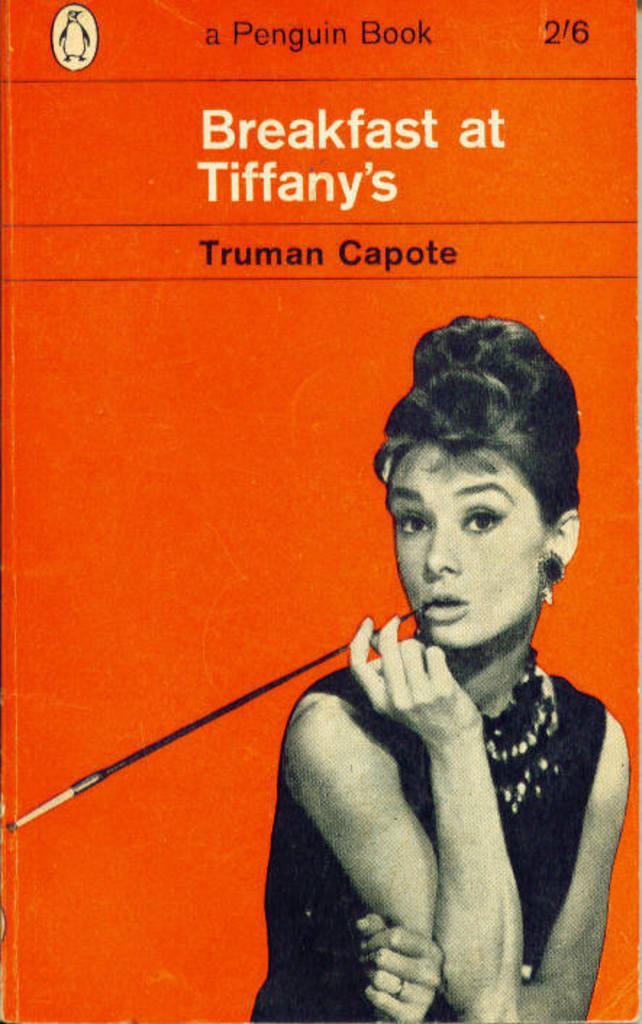Could you give a brief overview of what you see in this image? This is the poster where we can see a woman image and some text written on it. The woman is wearing black color dress and holding stick in her hand. 